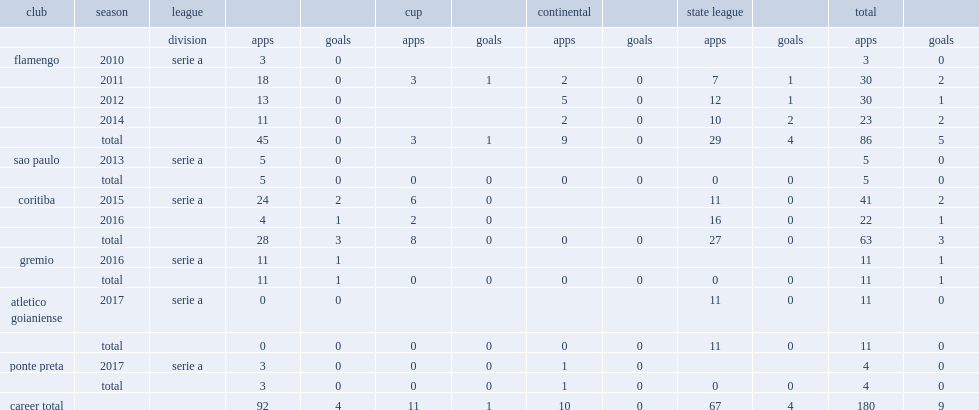Which league did negueba play from 2010 for flamengo? Serie a. 